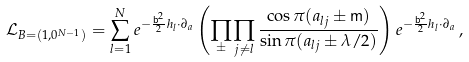Convert formula to latex. <formula><loc_0><loc_0><loc_500><loc_500>\mathcal { L } _ { B = ( 1 , 0 ^ { N - 1 } ) } = \sum _ { l = 1 } ^ { N } e ^ { - \frac { \mathsf b ^ { 2 } } { 2 } h _ { l } \cdot \partial _ { a } } \left ( \prod _ { \pm } \prod _ { j \neq l } \frac { \cos \pi ( a _ { l j } \pm \mathsf m ) } { \sin \pi ( a _ { l j } \pm \lambda / 2 ) } \right ) e ^ { - \frac { \mathsf b ^ { 2 } } { 2 } h _ { l } \cdot \partial _ { a } } \, ,</formula> 